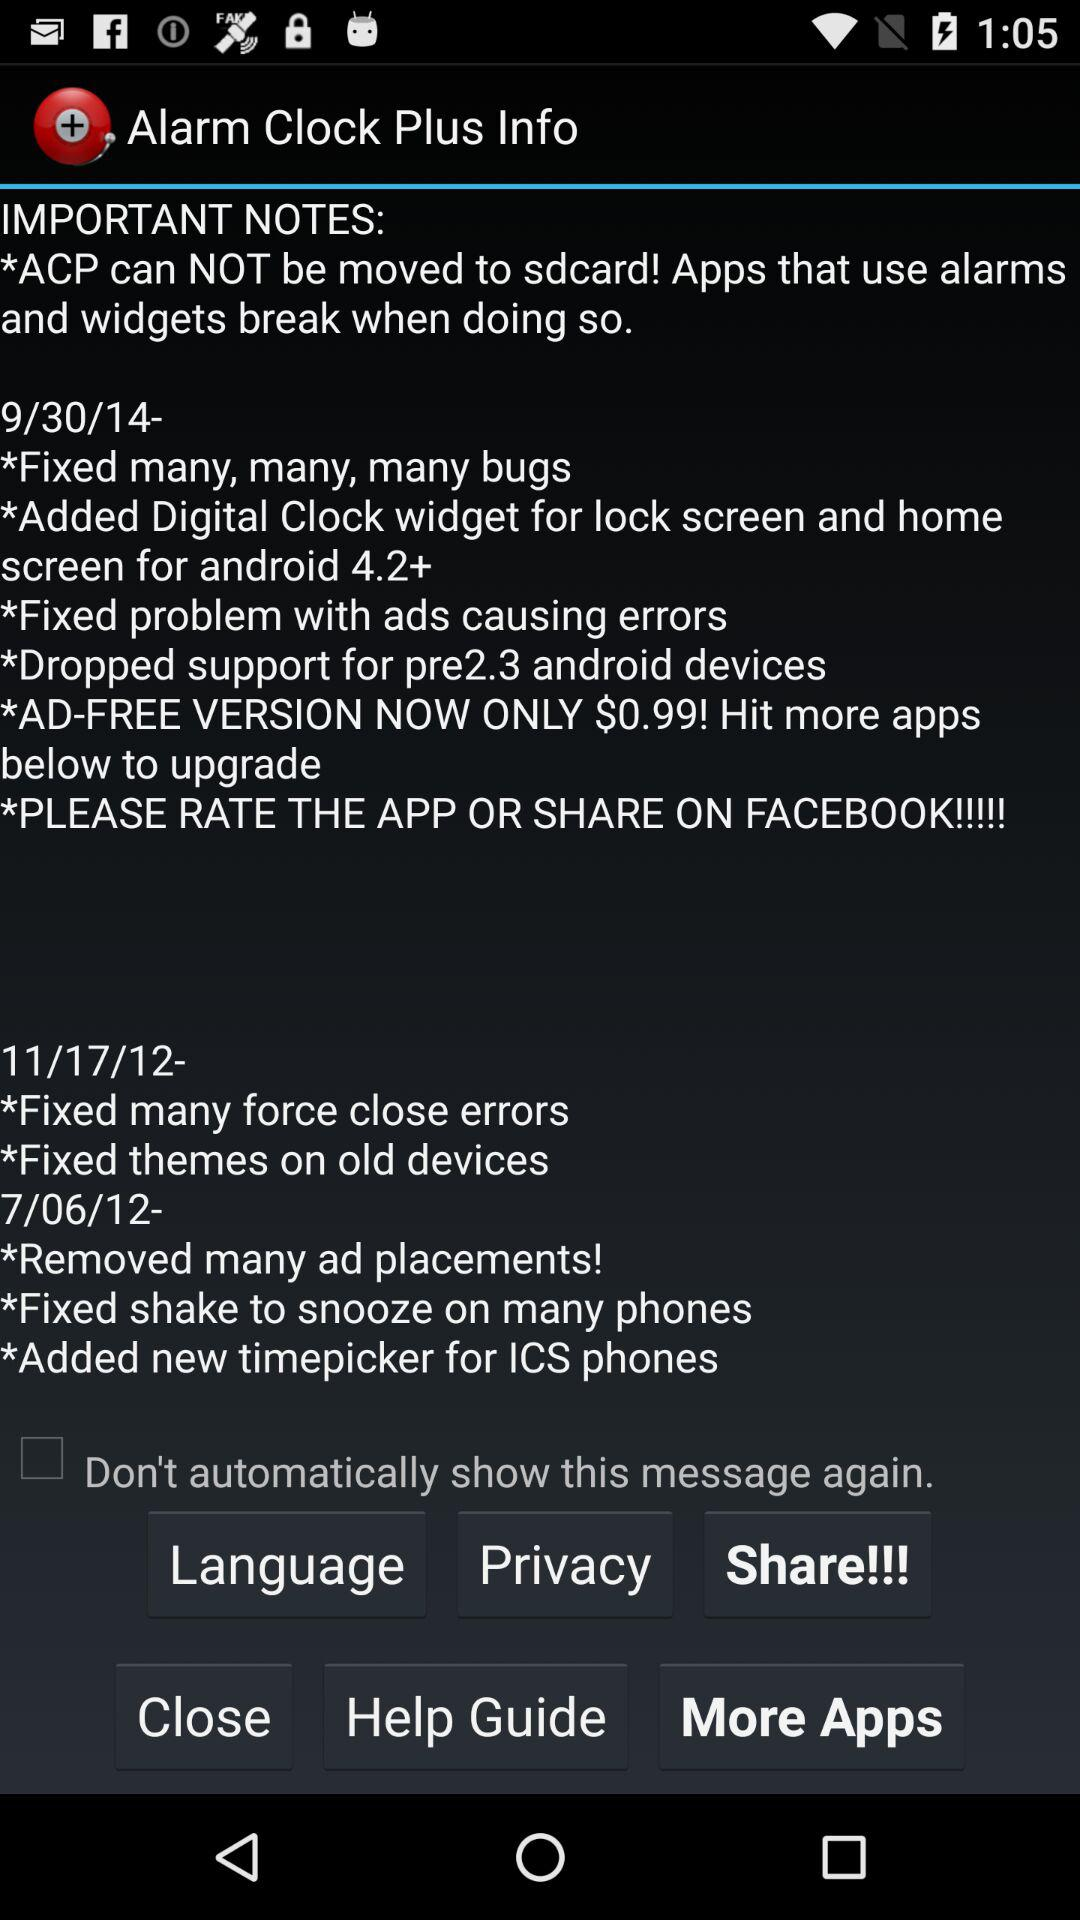What is the cost of the ad-free version of the application? The cost is $0.99. 